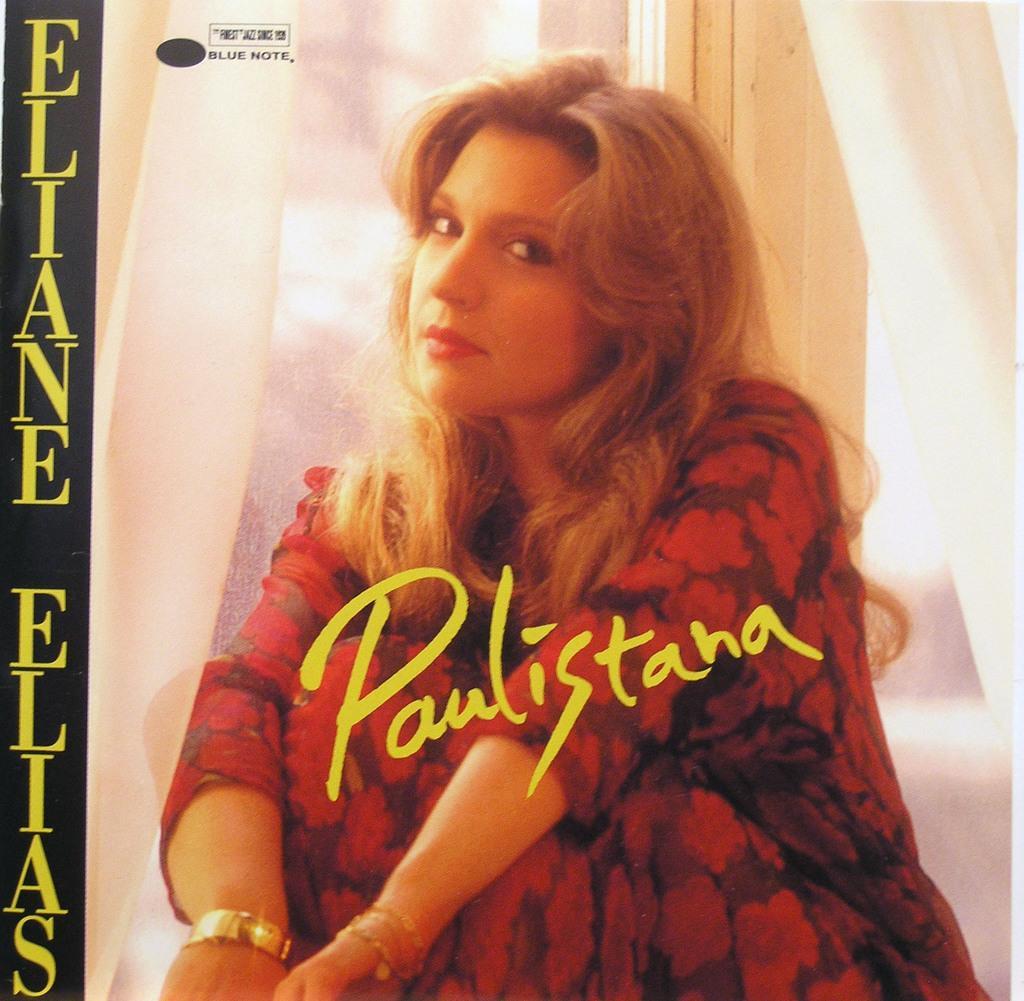Could you give a brief overview of what you see in this image? In this image in the center there is one woman who is sitting, and in the center and on the left side there is some text. In the background there is a window and some curtains. 